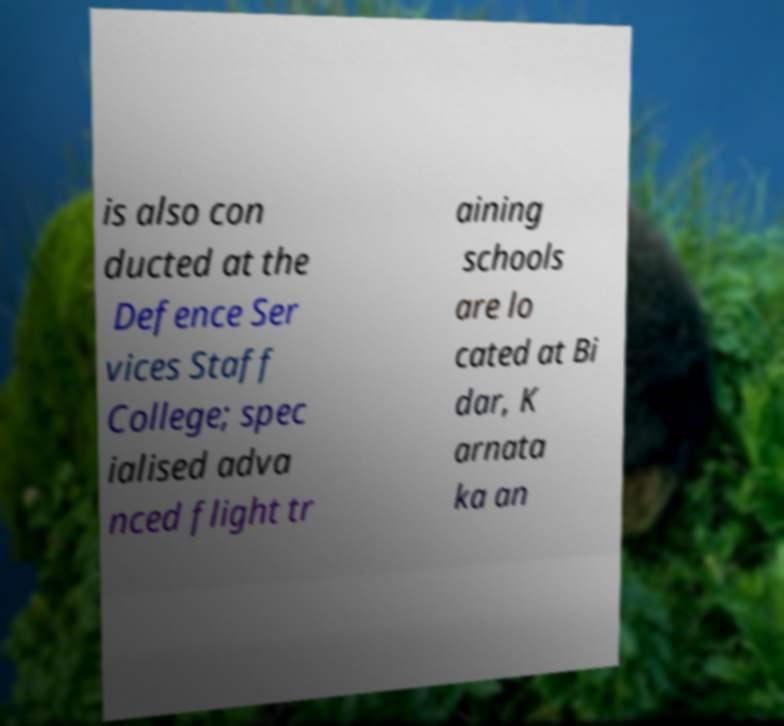What messages or text are displayed in this image? I need them in a readable, typed format. is also con ducted at the Defence Ser vices Staff College; spec ialised adva nced flight tr aining schools are lo cated at Bi dar, K arnata ka an 